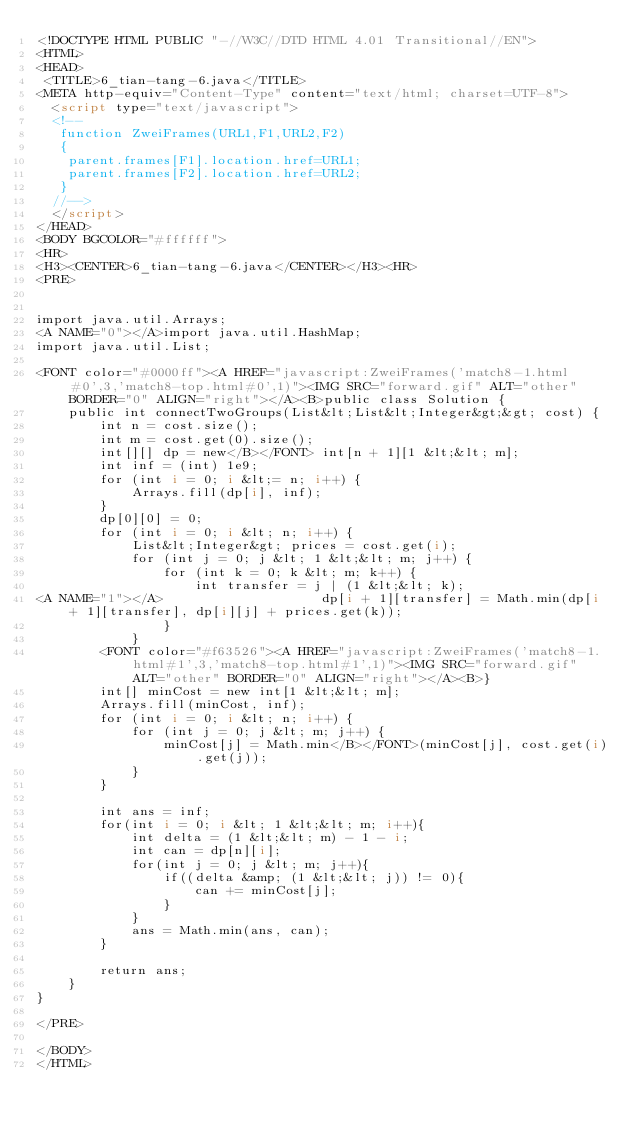Convert code to text. <code><loc_0><loc_0><loc_500><loc_500><_HTML_><!DOCTYPE HTML PUBLIC "-//W3C//DTD HTML 4.01 Transitional//EN">
<HTML>
<HEAD>
 <TITLE>6_tian-tang-6.java</TITLE>
<META http-equiv="Content-Type" content="text/html; charset=UTF-8">
  <script type="text/javascript">
  <!--
   function ZweiFrames(URL1,F1,URL2,F2)
   {
    parent.frames[F1].location.href=URL1;
    parent.frames[F2].location.href=URL2;
   }
  //-->
  </script>
</HEAD>
<BODY BGCOLOR="#ffffff">
<HR>
<H3><CENTER>6_tian-tang-6.java</CENTER></H3><HR>
<PRE>


import java.util.Arrays;
<A NAME="0"></A>import java.util.HashMap;
import java.util.List;

<FONT color="#0000ff"><A HREF="javascript:ZweiFrames('match8-1.html#0',3,'match8-top.html#0',1)"><IMG SRC="forward.gif" ALT="other" BORDER="0" ALIGN="right"></A><B>public class Solution {
    public int connectTwoGroups(List&lt;List&lt;Integer&gt;&gt; cost) {
        int n = cost.size();
        int m = cost.get(0).size();
        int[][] dp = new</B></FONT> int[n + 1][1 &lt;&lt; m];
        int inf = (int) 1e9;
        for (int i = 0; i &lt;= n; i++) {
            Arrays.fill(dp[i], inf);
        }
        dp[0][0] = 0;
        for (int i = 0; i &lt; n; i++) {
            List&lt;Integer&gt; prices = cost.get(i);
            for (int j = 0; j &lt; 1 &lt;&lt; m; j++) {
                for (int k = 0; k &lt; m; k++) {
                    int transfer = j | (1 &lt;&lt; k);
<A NAME="1"></A>                    dp[i + 1][transfer] = Math.min(dp[i + 1][transfer], dp[i][j] + prices.get(k));
                }
            }
        <FONT color="#f63526"><A HREF="javascript:ZweiFrames('match8-1.html#1',3,'match8-top.html#1',1)"><IMG SRC="forward.gif" ALT="other" BORDER="0" ALIGN="right"></A><B>}
        int[] minCost = new int[1 &lt;&lt; m];
        Arrays.fill(minCost, inf);
        for (int i = 0; i &lt; n; i++) {
            for (int j = 0; j &lt; m; j++) {
                minCost[j] = Math.min</B></FONT>(minCost[j], cost.get(i).get(j));
            }
        }
        
        int ans = inf;
        for(int i = 0; i &lt; 1 &lt;&lt; m; i++){
            int delta = (1 &lt;&lt; m) - 1 - i;
            int can = dp[n][i];
            for(int j = 0; j &lt; m; j++){
                if((delta &amp; (1 &lt;&lt; j)) != 0){
                    can += minCost[j];
                }
            }
            ans = Math.min(ans, can);
        }
        
        return ans;
    }
}

</PRE>

</BODY>
</HTML>
</code> 